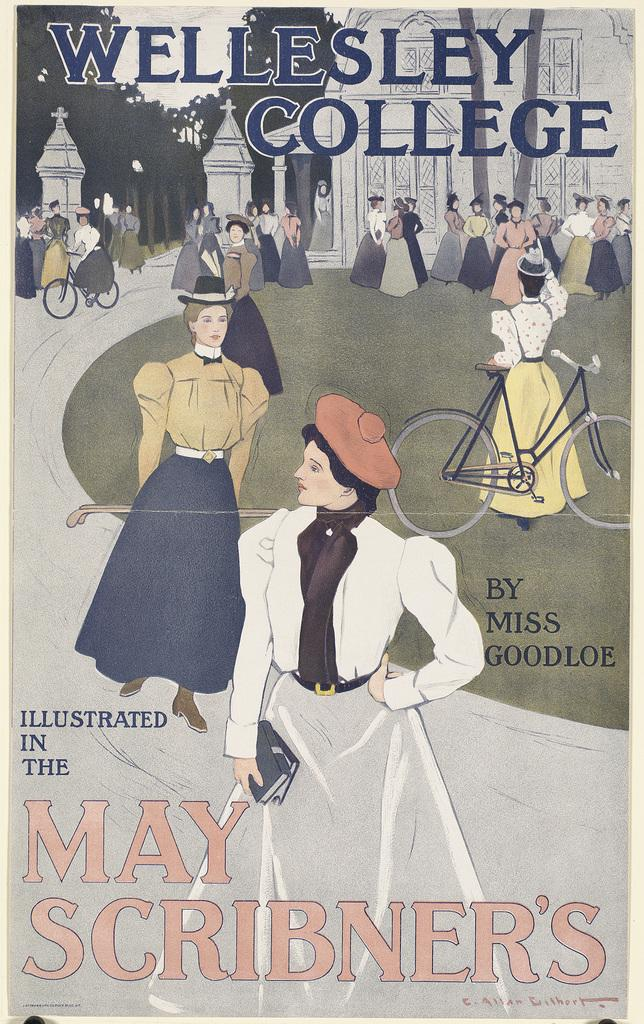<image>
Render a clear and concise summary of the photo. A poster for Wellesley College with women on it. 